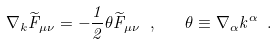Convert formula to latex. <formula><loc_0><loc_0><loc_500><loc_500>\nabla _ { k } \widetilde { F } _ { \mu \nu } = - \frac { 1 } { 2 } \theta \widetilde { F } _ { \mu \nu } \ , \quad \theta \equiv \nabla _ { \alpha } k ^ { \alpha } \ .</formula> 